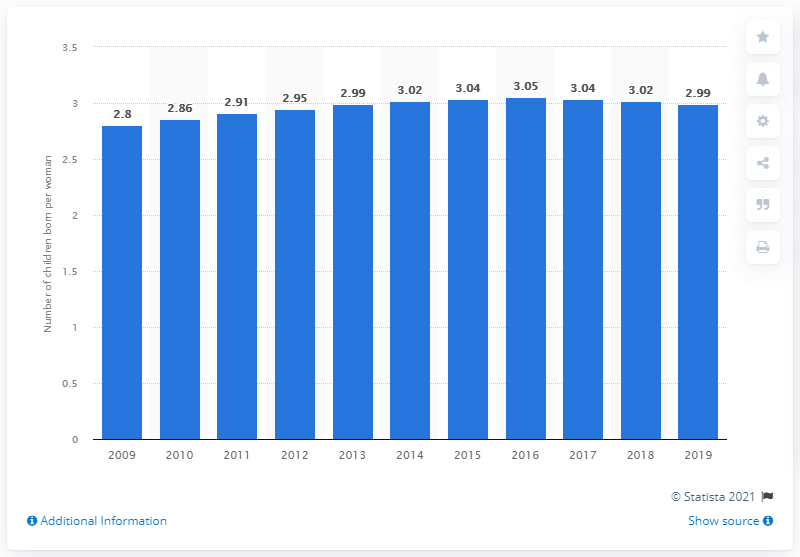Specify some key components in this picture. In 2019, Algeria's fertility rate was 2.99. 